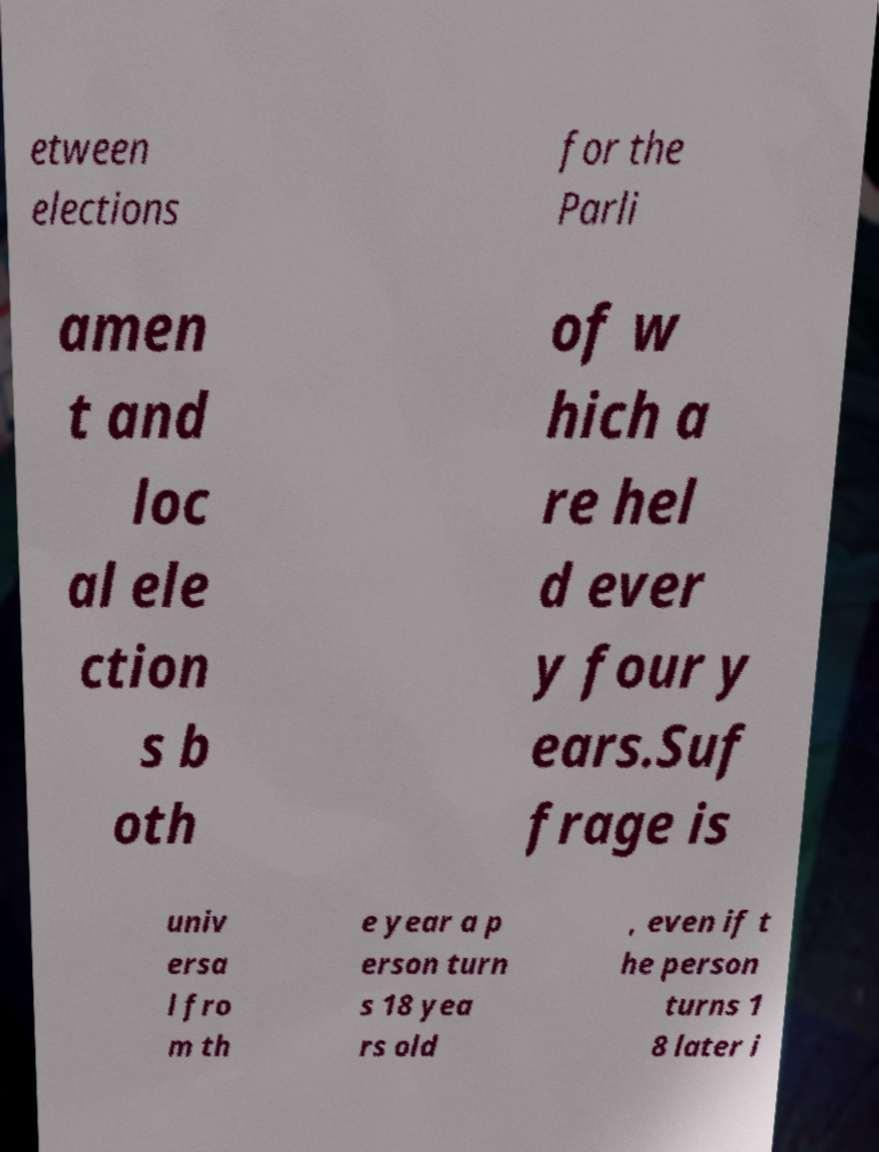Please read and relay the text visible in this image. What does it say? etween elections for the Parli amen t and loc al ele ction s b oth of w hich a re hel d ever y four y ears.Suf frage is univ ersa l fro m th e year a p erson turn s 18 yea rs old , even if t he person turns 1 8 later i 